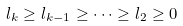Convert formula to latex. <formula><loc_0><loc_0><loc_500><loc_500>l _ { k } \geq l _ { k - 1 } \geq \dots \geq l _ { 2 } \geq 0</formula> 